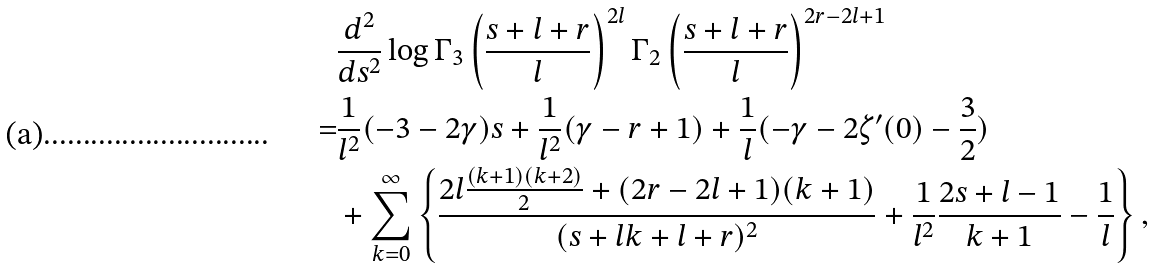<formula> <loc_0><loc_0><loc_500><loc_500>& \frac { d ^ { 2 } } { d s ^ { 2 } } \log \Gamma _ { 3 } \left ( \frac { s + l + r } { l } \right ) ^ { 2 l } \Gamma _ { 2 } \left ( \frac { s + l + r } { l } \right ) ^ { 2 r - 2 l + 1 } \\ = & \frac { 1 } { l ^ { 2 } } ( - 3 - 2 \gamma ) s + \frac { 1 } { l ^ { 2 } } ( \gamma - r + 1 ) + \frac { 1 } { l } ( - \gamma - 2 \zeta ^ { \prime } ( 0 ) - \frac { 3 } { 2 } ) \\ & + \sum _ { k = 0 } ^ { \infty } \left \{ \frac { 2 l \frac { ( k + 1 ) ( k + 2 ) } { 2 } + ( 2 r - 2 l + 1 ) ( k + 1 ) } { ( s + l k + l + r ) ^ { 2 } } + \frac { 1 } { l ^ { 2 } } \frac { 2 s + l - 1 } { k + 1 } - \frac { 1 } { l } \right \} ,</formula> 